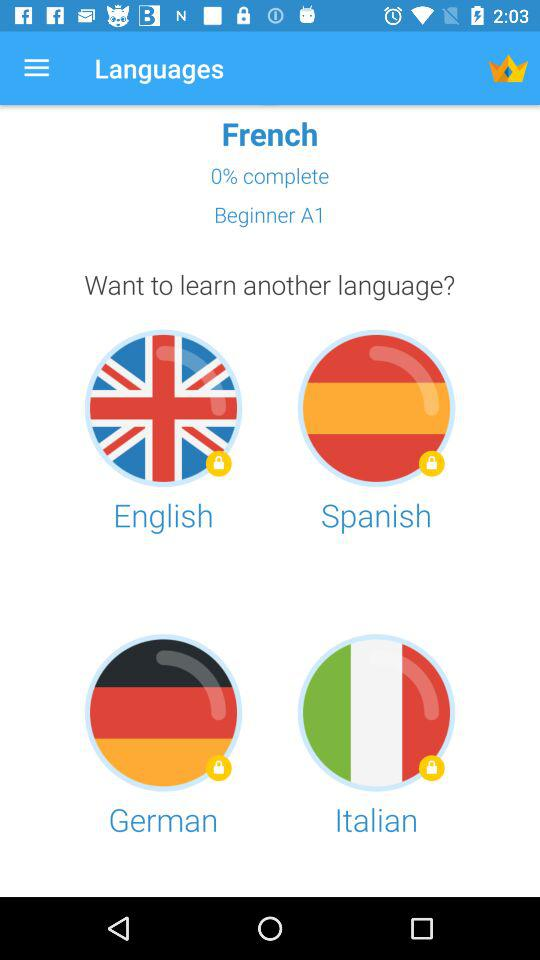What is the percentage of the course completed? The percentage of the course completed is 0. 